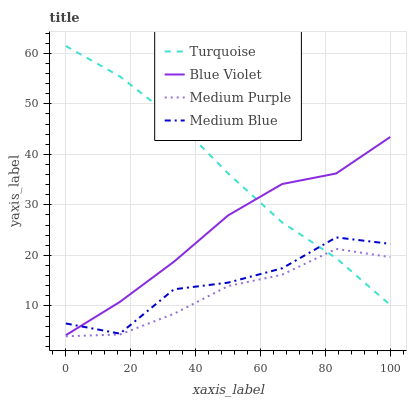Does Medium Purple have the minimum area under the curve?
Answer yes or no. Yes. Does Turquoise have the maximum area under the curve?
Answer yes or no. Yes. Does Medium Blue have the minimum area under the curve?
Answer yes or no. No. Does Medium Blue have the maximum area under the curve?
Answer yes or no. No. Is Turquoise the smoothest?
Answer yes or no. Yes. Is Medium Blue the roughest?
Answer yes or no. Yes. Is Medium Blue the smoothest?
Answer yes or no. No. Is Turquoise the roughest?
Answer yes or no. No. Does Medium Purple have the lowest value?
Answer yes or no. Yes. Does Medium Blue have the lowest value?
Answer yes or no. No. Does Turquoise have the highest value?
Answer yes or no. Yes. Does Medium Blue have the highest value?
Answer yes or no. No. Is Medium Purple less than Blue Violet?
Answer yes or no. Yes. Is Blue Violet greater than Medium Purple?
Answer yes or no. Yes. Does Turquoise intersect Medium Purple?
Answer yes or no. Yes. Is Turquoise less than Medium Purple?
Answer yes or no. No. Is Turquoise greater than Medium Purple?
Answer yes or no. No. Does Medium Purple intersect Blue Violet?
Answer yes or no. No. 